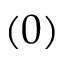Convert formula to latex. <formula><loc_0><loc_0><loc_500><loc_500>( 0 )</formula> 